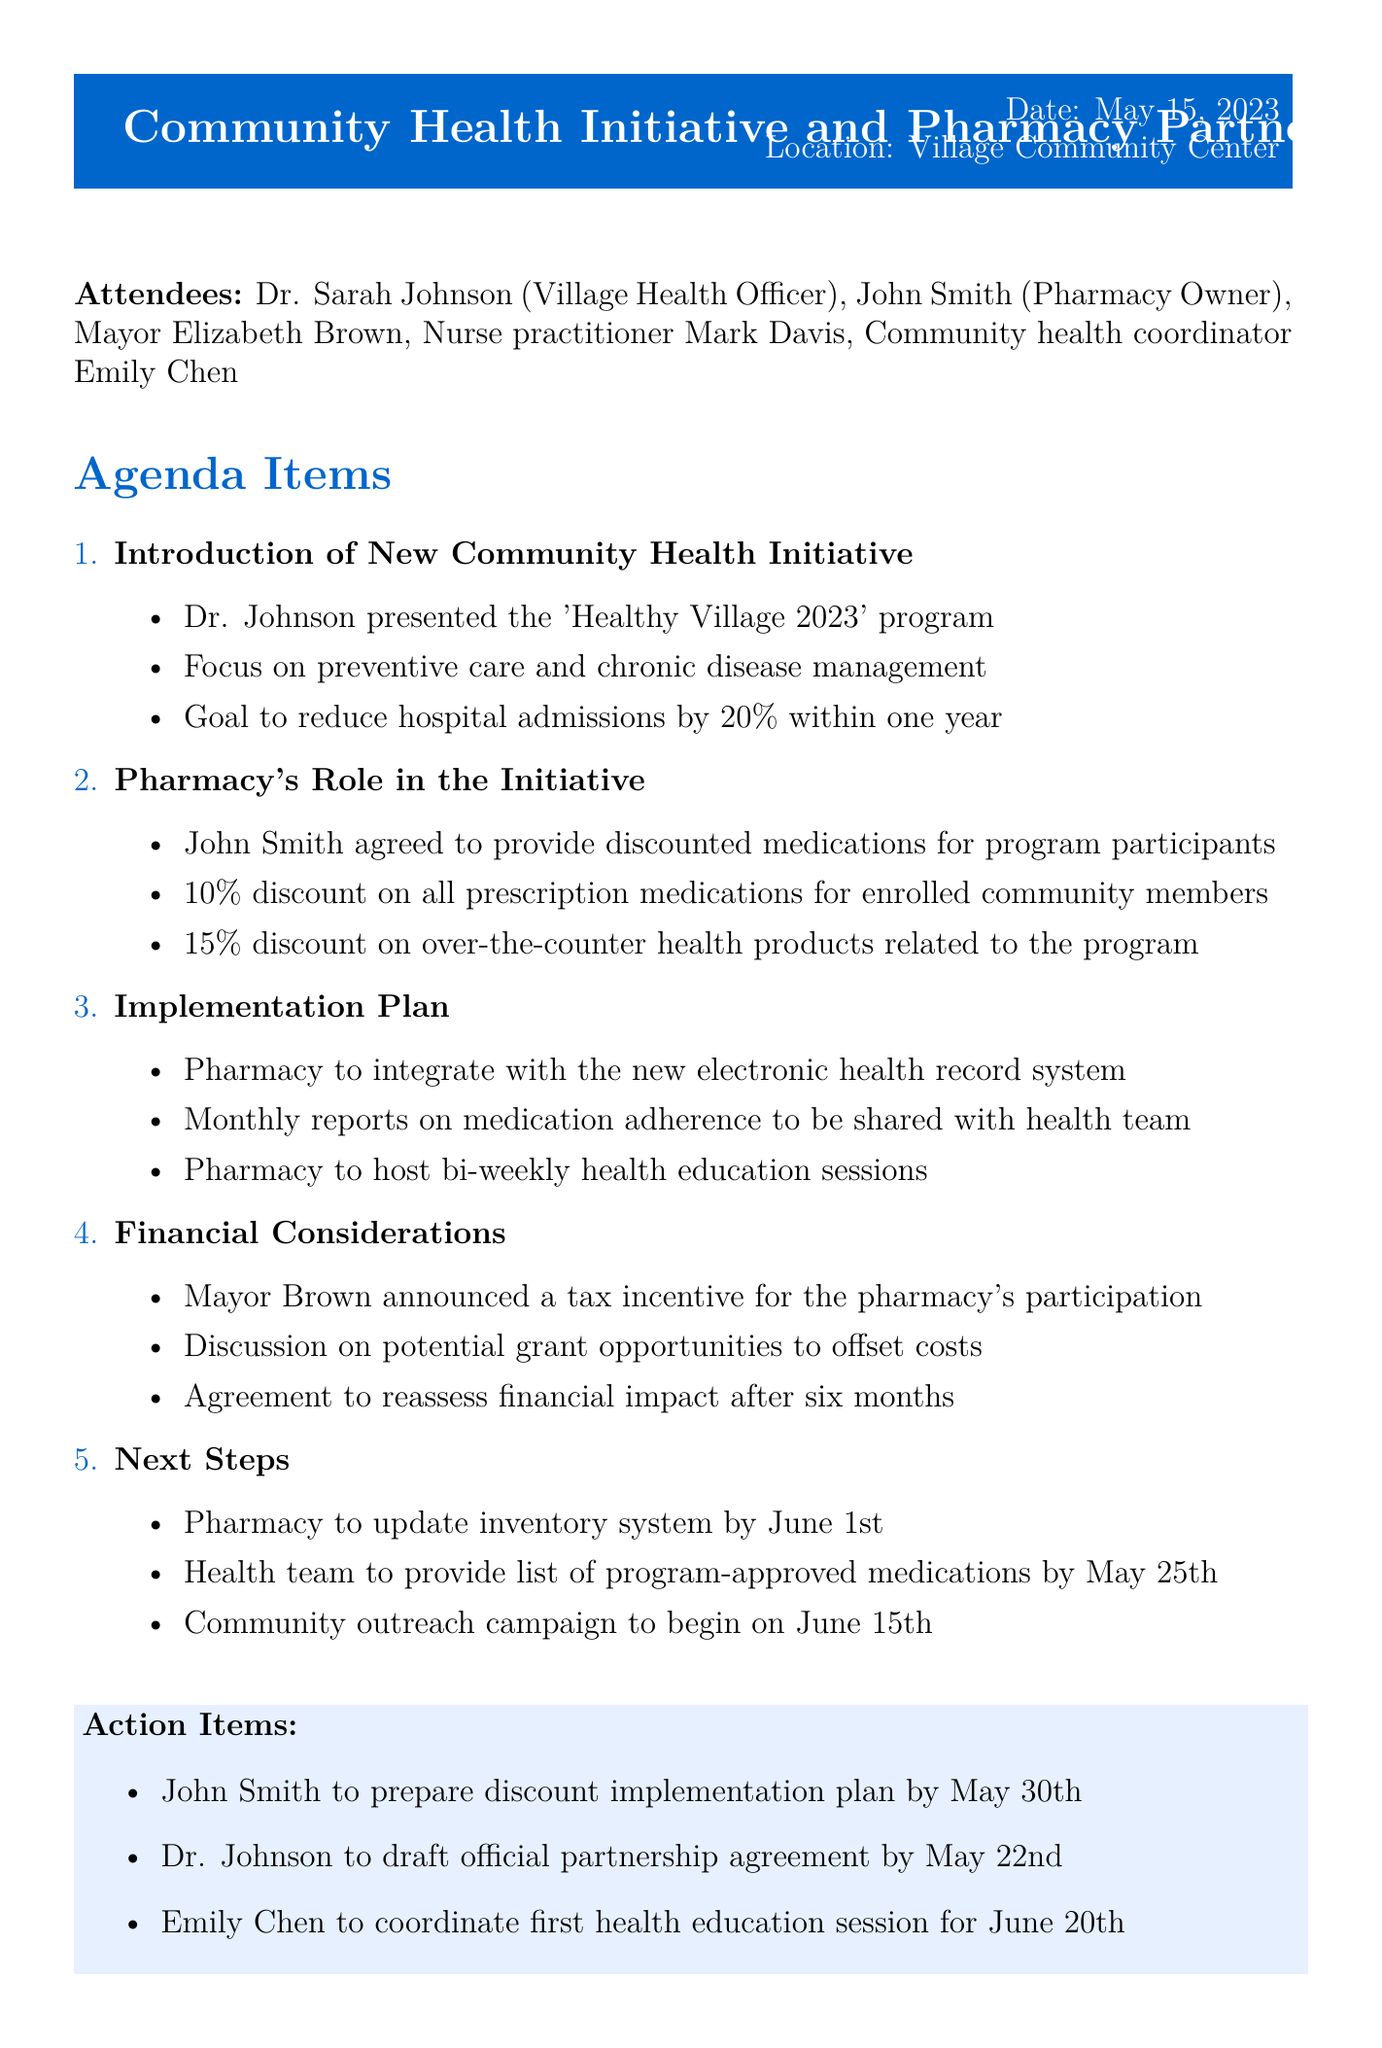What is the title of the meeting? The title of the meeting is stated at the beginning of the document.
Answer: Community Health Initiative and Pharmacy Partnership Who is the Village Health Officer? The document lists the attendees, including their roles.
Answer: Dr. Sarah Johnson What is the main goal of the 'Healthy Village 2023' program? The agenda item describes the goals of the community health initiative.
Answer: Reduce hospital admissions by 20% within one year What discount does the pharmacy offer on prescription medications? The pharmacy's role in the initiative includes specific discount percentages.
Answer: 10% discount When is the community outreach campaign set to begin? The timing of the outreach campaign is mentioned under the next steps.
Answer: June 15th What financial incentive was announced by Mayor Brown? Financial considerations are discussed in the agenda, including incentives.
Answer: Tax incentive How often will the pharmacy host health education sessions? The implementation plan mentions the frequency of health education sessions.
Answer: Bi-weekly By when does John Smith need to prepare the discount implementation plan? The action items list specific deadlines for tasks.
Answer: May 30th What is the location of the meeting? The document specifies where the meeting took place.
Answer: Village Community Center 